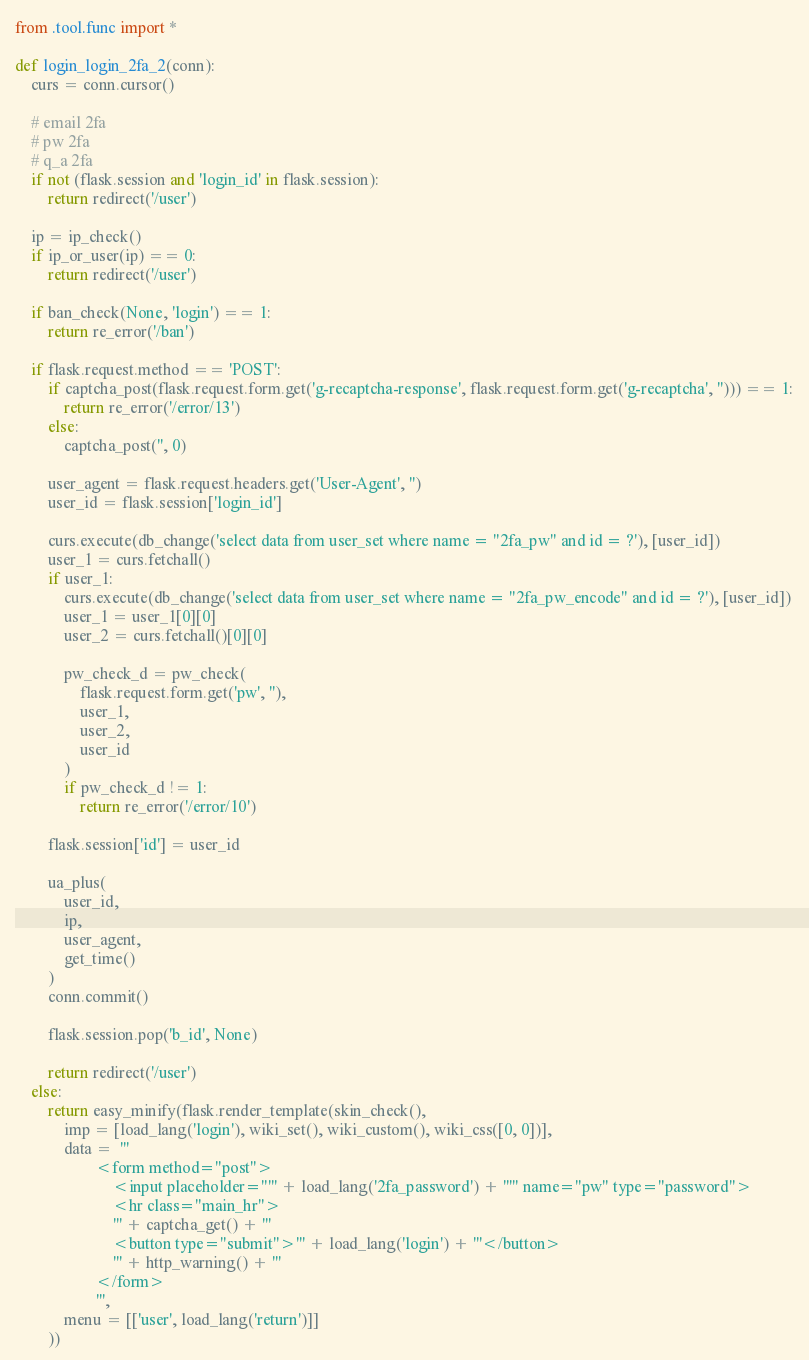Convert code to text. <code><loc_0><loc_0><loc_500><loc_500><_Python_>from .tool.func import *

def login_login_2fa_2(conn):
    curs = conn.cursor()

    # email 2fa
    # pw 2fa
    # q_a 2fa
    if not (flask.session and 'login_id' in flask.session):
        return redirect('/user')

    ip = ip_check()
    if ip_or_user(ip) == 0:
        return redirect('/user')

    if ban_check(None, 'login') == 1:
        return re_error('/ban')

    if flask.request.method == 'POST':
        if captcha_post(flask.request.form.get('g-recaptcha-response', flask.request.form.get('g-recaptcha', ''))) == 1:
            return re_error('/error/13')
        else:
            captcha_post('', 0)

        user_agent = flask.request.headers.get('User-Agent', '')
        user_id = flask.session['login_id']

        curs.execute(db_change('select data from user_set where name = "2fa_pw" and id = ?'), [user_id])
        user_1 = curs.fetchall()
        if user_1:
            curs.execute(db_change('select data from user_set where name = "2fa_pw_encode" and id = ?'), [user_id])
            user_1 = user_1[0][0]
            user_2 = curs.fetchall()[0][0]

            pw_check_d = pw_check(
                flask.request.form.get('pw', ''),
                user_1,
                user_2,
                user_id
            )
            if pw_check_d != 1:
                return re_error('/error/10')

        flask.session['id'] = user_id

        ua_plus(
            user_id, 
            ip, 
            user_agent, 
            get_time()
        )
        conn.commit()

        flask.session.pop('b_id', None)

        return redirect('/user')
    else:
        return easy_minify(flask.render_template(skin_check(),
            imp = [load_lang('login'), wiki_set(), wiki_custom(), wiki_css([0, 0])],
            data =  '''
                    <form method="post">
                        <input placeholder="''' + load_lang('2fa_password') + '''" name="pw" type="password">
                        <hr class="main_hr">
                        ''' + captcha_get() + '''
                        <button type="submit">''' + load_lang('login') + '''</button>
                        ''' + http_warning() + '''
                    </form>
                    ''',
            menu = [['user', load_lang('return')]]
        ))</code> 